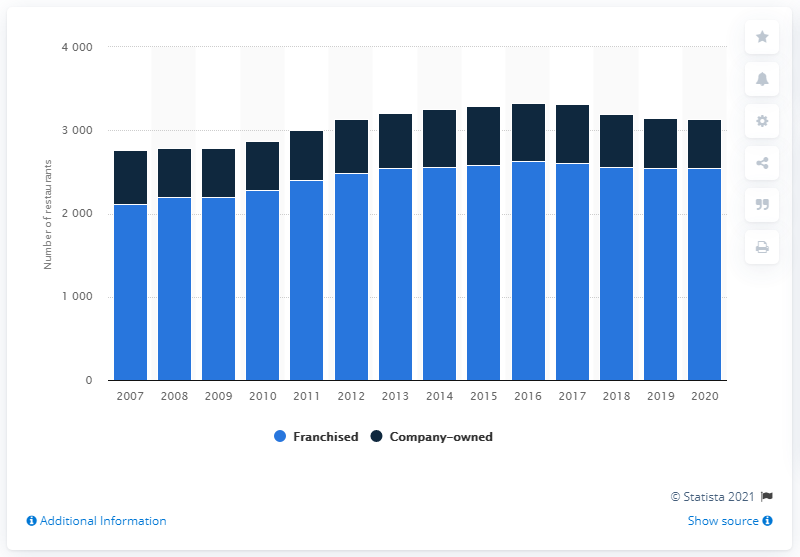Specify some key components in this picture. In 2020, there were 588 company-owned restaurants in the United States. 